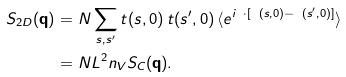<formula> <loc_0><loc_0><loc_500><loc_500>S _ { 2 D } ( { \mathbf q } ) & = N \sum _ { s , s ^ { \prime } } t ( s , 0 ) \, t ( s ^ { \prime } , 0 ) \, \langle e ^ { i { \mathbf q } \cdot [ { \mathbf R } ( s , 0 ) - { \mathbf R } ( s ^ { \prime } , 0 ) ] } \rangle \\ & = N L ^ { 2 } n _ { V } S _ { C } ( { \mathbf q } ) .</formula> 